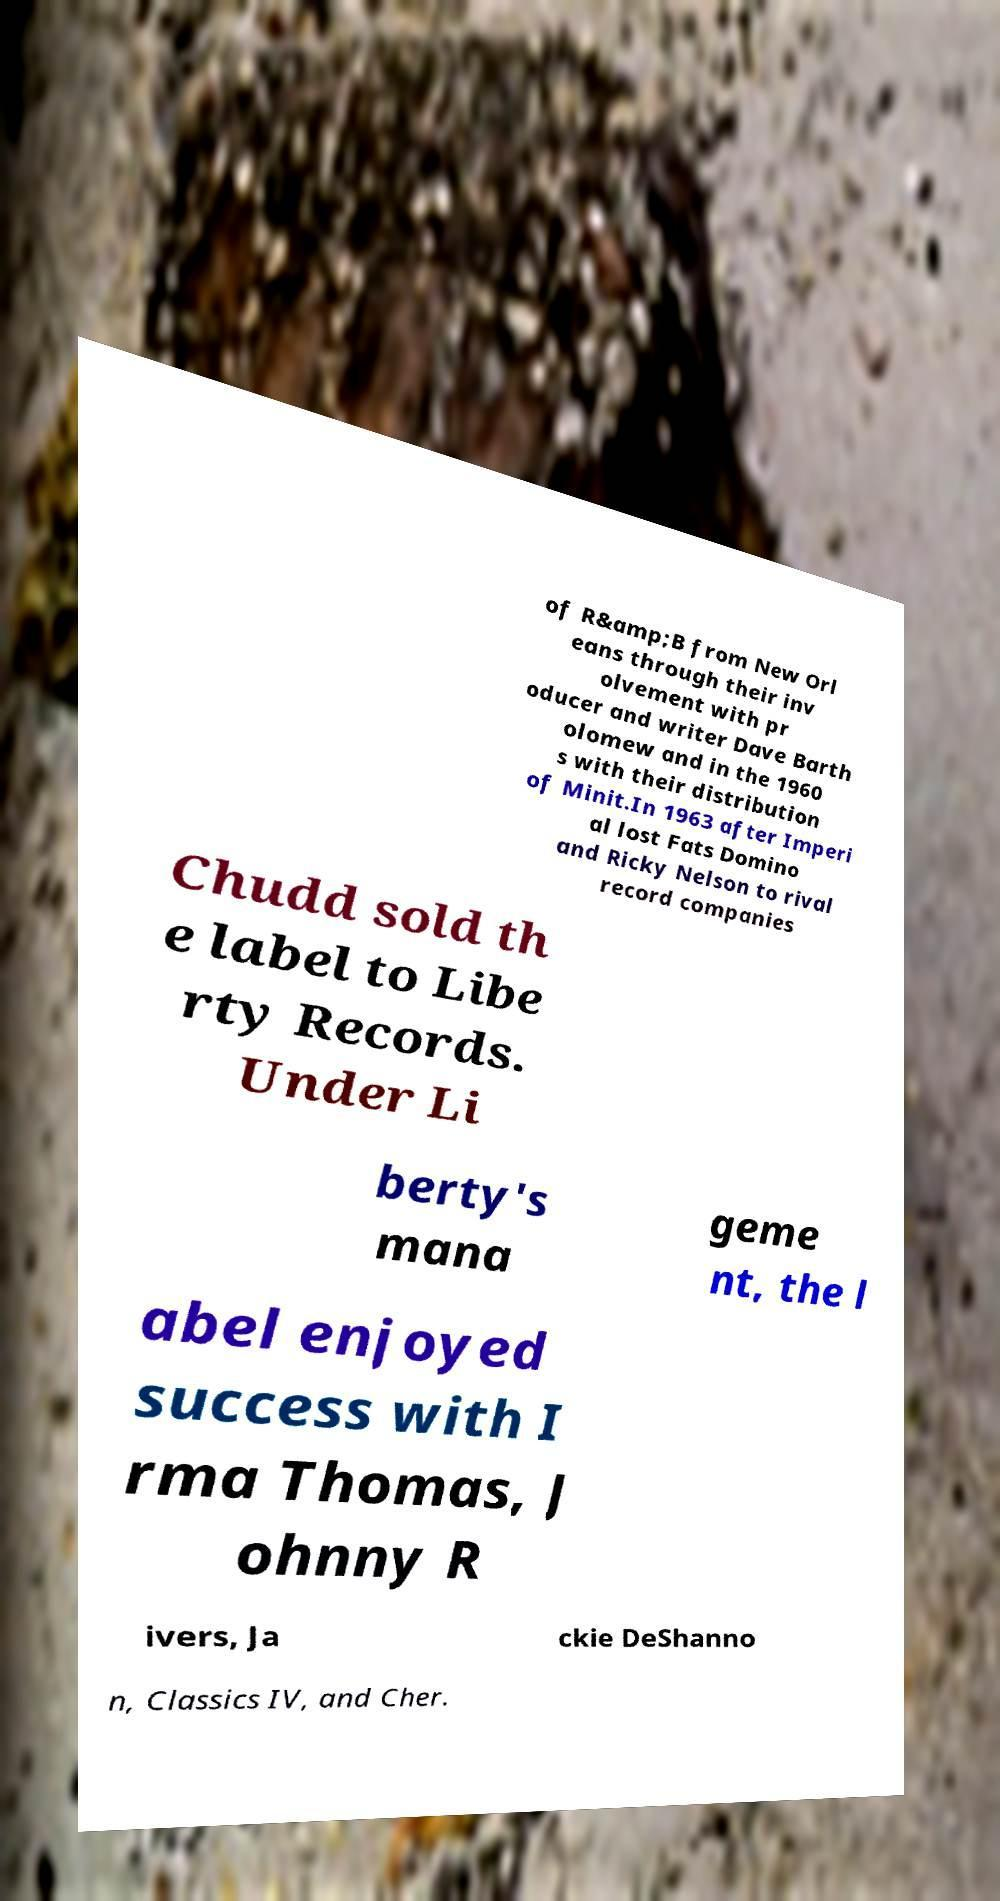Could you extract and type out the text from this image? of R&amp;B from New Orl eans through their inv olvement with pr oducer and writer Dave Barth olomew and in the 1960 s with their distribution of Minit.In 1963 after Imperi al lost Fats Domino and Ricky Nelson to rival record companies Chudd sold th e label to Libe rty Records. Under Li berty's mana geme nt, the l abel enjoyed success with I rma Thomas, J ohnny R ivers, Ja ckie DeShanno n, Classics IV, and Cher. 